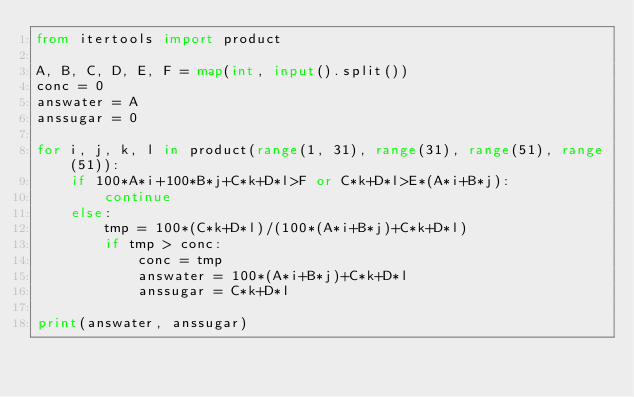Convert code to text. <code><loc_0><loc_0><loc_500><loc_500><_Python_>from itertools import product

A, B, C, D, E, F = map(int, input().split())
conc = 0
answater = A
anssugar = 0

for i, j, k, l in product(range(1, 31), range(31), range(51), range(51)):
    if 100*A*i+100*B*j+C*k+D*l>F or C*k+D*l>E*(A*i+B*j):
        continue
    else:
        tmp = 100*(C*k+D*l)/(100*(A*i+B*j)+C*k+D*l)
        if tmp > conc:
            conc = tmp
            answater = 100*(A*i+B*j)+C*k+D*l
            anssugar = C*k+D*l

print(answater, anssugar)</code> 